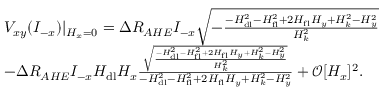Convert formula to latex. <formula><loc_0><loc_0><loc_500><loc_500>\begin{array} { r l } & { V _ { x y } ( I _ { - x } ) | { _ { H _ { x } = 0 } } = \Delta R _ { A H E } I _ { - x } \sqrt { - \frac { - H _ { d l } ^ { 2 } - H _ { f l } ^ { 2 } + 2 H _ { f l } H _ { y } + H _ { k } ^ { 2 } - H _ { y } ^ { 2 } } { H _ { k } ^ { 2 } } } } \\ & { - \Delta R _ { A H E } I _ { - x } H _ { d l } H _ { x } \frac { \sqrt { \frac { - H _ { d l } ^ { 2 } - H _ { f l } ^ { 2 } + 2 H _ { f l } H _ { y } + H _ { k } ^ { 2 } - H _ { y } ^ { 2 } } { H _ { k } ^ { 2 } } } } { - H _ { d l } ^ { 2 } - H _ { f l } ^ { 2 } + 2 H _ { f l } H _ { y } + H _ { k } ^ { 2 } - H _ { y } ^ { 2 } } + \mathcal { O } [ H _ { x } ] ^ { 2 } . } \end{array}</formula> 